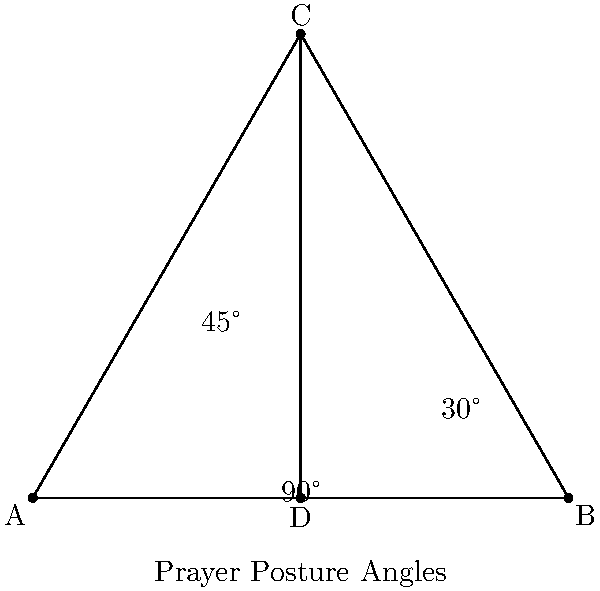In the context of comparative religious studies, analyze the prayer posture angles depicted in the diagram. Which angle most closely corresponds to the prostration angle in Islamic prayer (sujud), and how does this compare to kneeling postures in other Abrahamic traditions? To answer this question, let's analyze the angles in the diagram and compare them to known prayer postures:

1. The diagram shows three main angles: 30°, 45°, and 90°.

2. In Islamic prayer (salah), the prostration (sujud) involves touching the forehead to the ground. This creates an acute angle between the upper body and the ground.

3. The angle of prostration in Islam is typically closer to 30° than the other angles shown. This allows the forehead to touch the ground while the knees are bent.

4. In comparison, kneeling postures in other Abrahamic traditions:
   a) Christianity: Kneeling often involves a more upright posture, closer to 90°.
   b) Judaism: Full prostration is rare in modern practice, but when done, it's similar to the Islamic posture.

5. The 45° angle could represent an intermediate position or a transitional movement in various prayer practices.

6. From a theological perspective, the lower angle of Islamic prostration symbolizes complete submission to God, while the more upright kneeling in some Christian traditions can represent a dialogue-like relationship with the Divine.

7. It's important to note that prayer postures can vary within each tradition and have evolved over time.

Therefore, the 30° angle most closely corresponds to the Islamic prostration (sujud), representing a more acute angle than typical kneeling postures in some other Abrahamic traditions.
Answer: 30°, symbolizing complete submission in Islamic prostration (sujud), contrasting with more upright kneeling in some other Abrahamic traditions. 